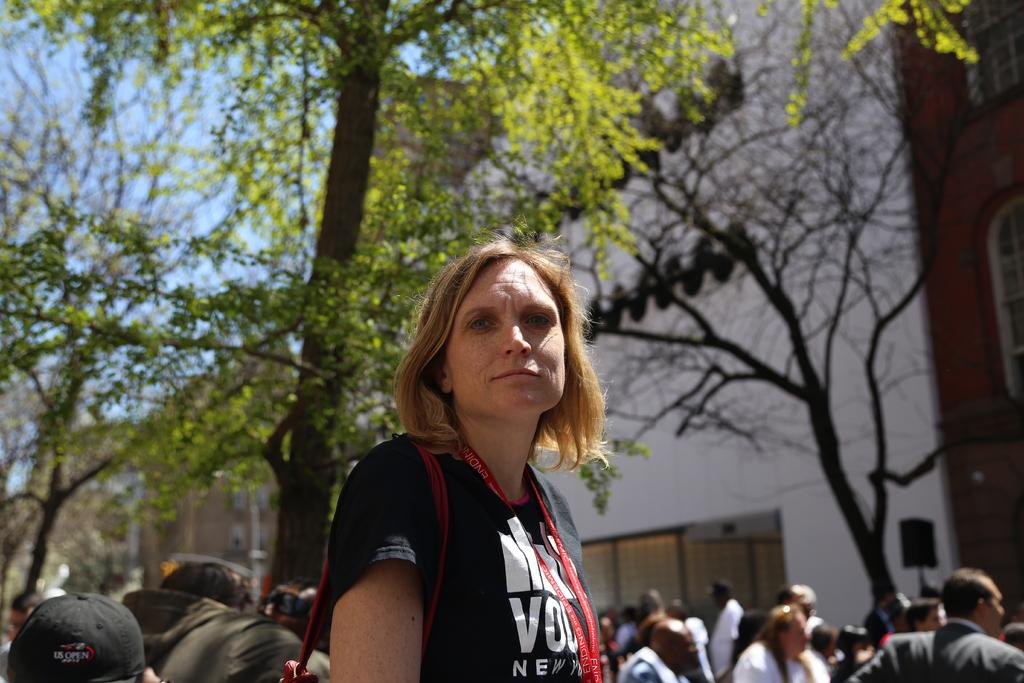How many people can be seen in the image? There are persons visible in the image. Can you describe the woman in the foreground? A woman wearing a black color t-shirt is in the foreground. What type of vegetation is present in the image? There are trees in the middle of the image. What is visible in the background of the image? The sky is visible in the image. What type of poison is being used by the society depicted in the image? There is no reference to poison or society in the image, so it is not possible to answer that question. 